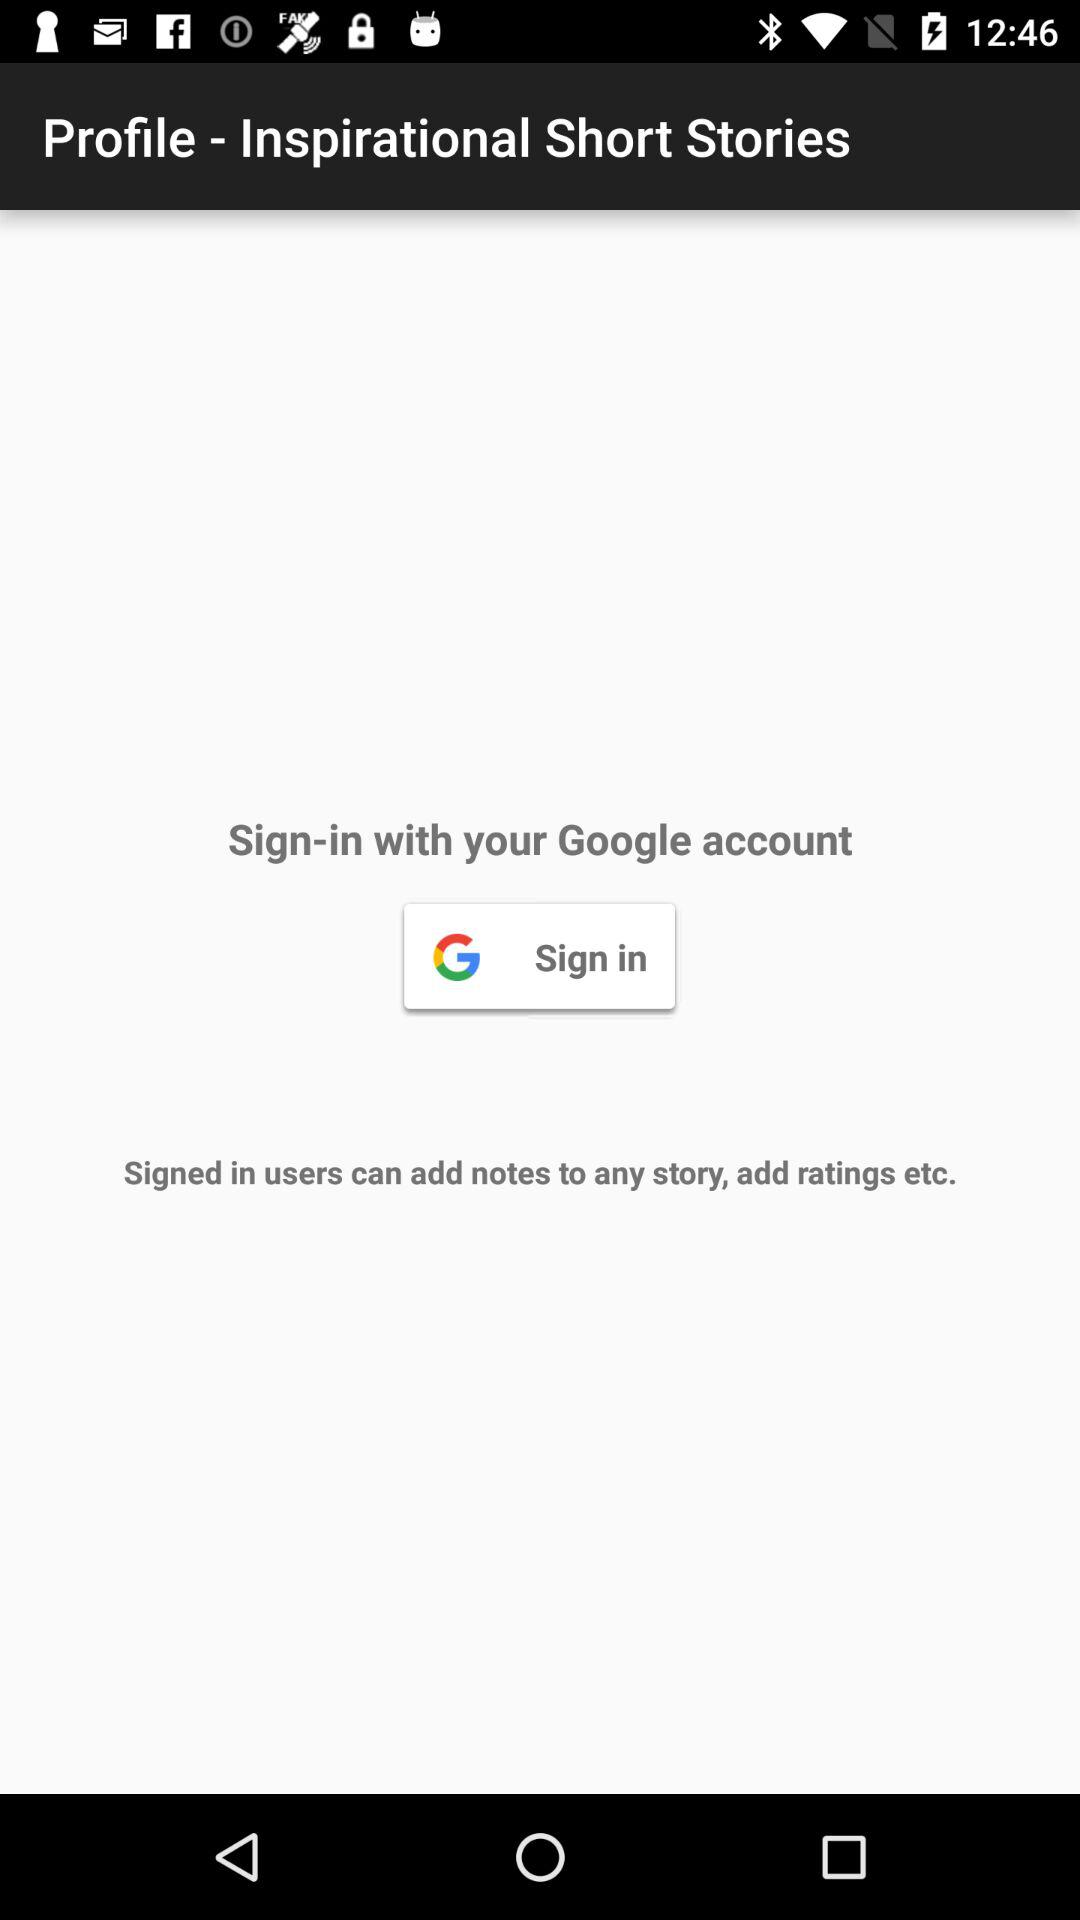Through what account can we log in? You can log in through your Google account. 